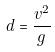Convert formula to latex. <formula><loc_0><loc_0><loc_500><loc_500>d = \frac { v ^ { 2 } } { g }</formula> 